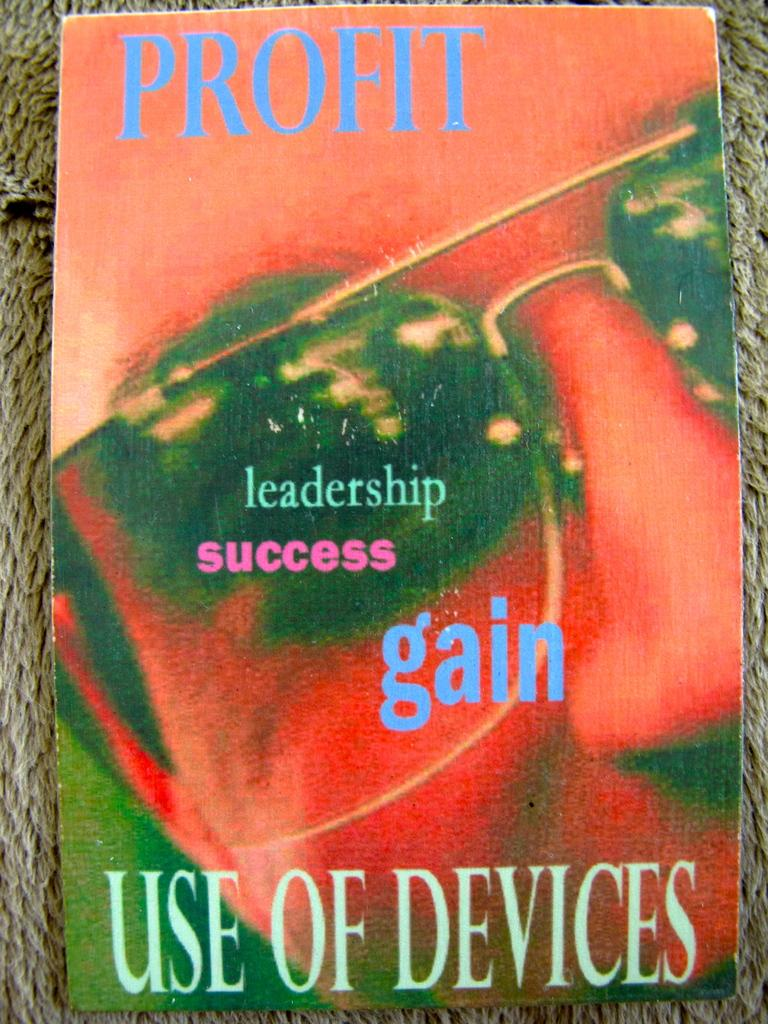<image>
Share a concise interpretation of the image provided. Profit use of devices that includes leadership success gain. 